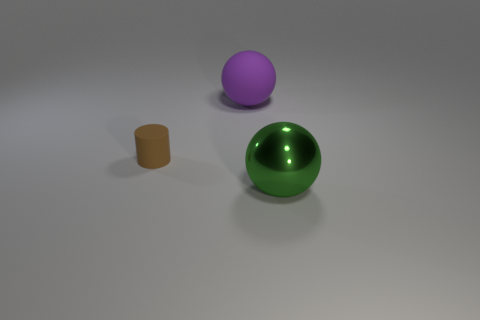Add 1 large brown objects. How many objects exist? 4 Subtract all cylinders. How many objects are left? 2 Subtract all matte balls. Subtract all small gray metal cylinders. How many objects are left? 2 Add 1 green objects. How many green objects are left? 2 Add 2 big matte cylinders. How many big matte cylinders exist? 2 Subtract 0 blue balls. How many objects are left? 3 